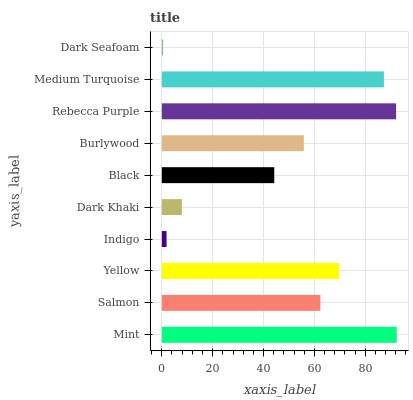Is Dark Seafoam the minimum?
Answer yes or no. Yes. Is Mint the maximum?
Answer yes or no. Yes. Is Salmon the minimum?
Answer yes or no. No. Is Salmon the maximum?
Answer yes or no. No. Is Mint greater than Salmon?
Answer yes or no. Yes. Is Salmon less than Mint?
Answer yes or no. Yes. Is Salmon greater than Mint?
Answer yes or no. No. Is Mint less than Salmon?
Answer yes or no. No. Is Salmon the high median?
Answer yes or no. Yes. Is Burlywood the low median?
Answer yes or no. Yes. Is Burlywood the high median?
Answer yes or no. No. Is Yellow the low median?
Answer yes or no. No. 